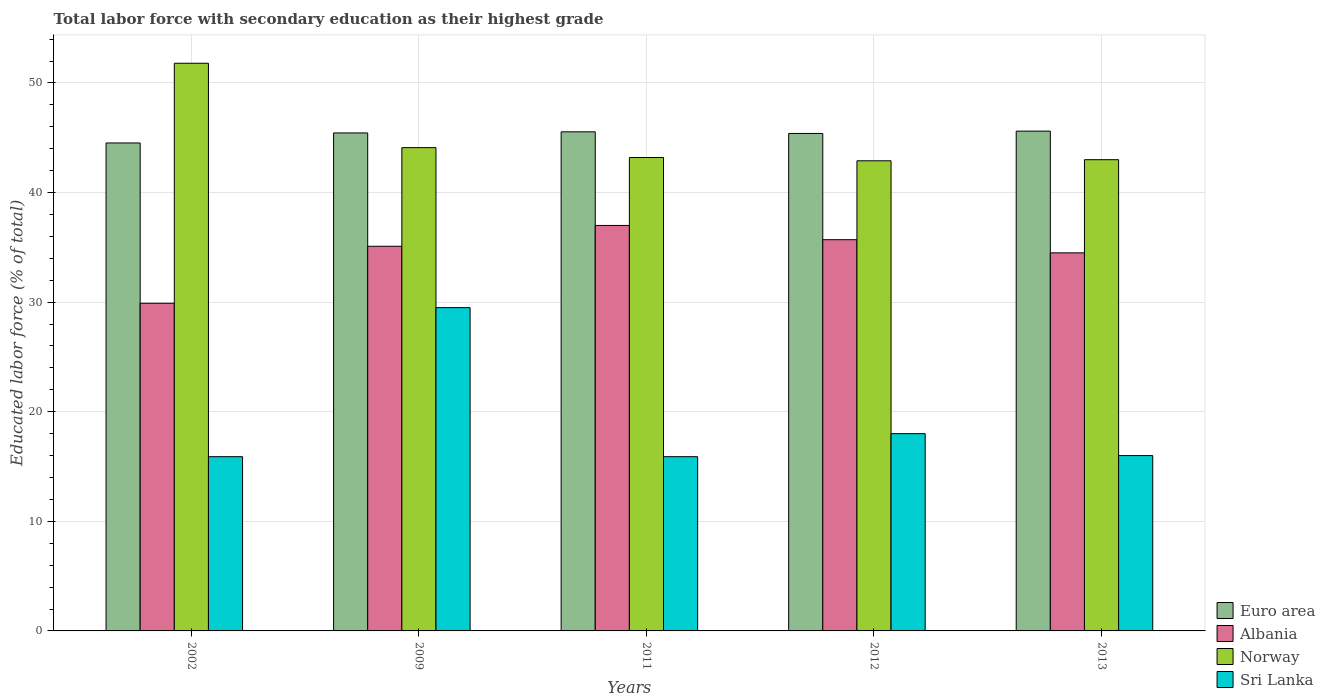How many different coloured bars are there?
Provide a short and direct response. 4. How many groups of bars are there?
Provide a short and direct response. 5. How many bars are there on the 3rd tick from the right?
Offer a terse response. 4. In how many cases, is the number of bars for a given year not equal to the number of legend labels?
Your answer should be very brief. 0. What is the percentage of total labor force with primary education in Euro area in 2011?
Your answer should be very brief. 45.54. Across all years, what is the maximum percentage of total labor force with primary education in Sri Lanka?
Offer a terse response. 29.5. Across all years, what is the minimum percentage of total labor force with primary education in Albania?
Provide a succinct answer. 29.9. In which year was the percentage of total labor force with primary education in Norway minimum?
Keep it short and to the point. 2012. What is the total percentage of total labor force with primary education in Euro area in the graph?
Provide a succinct answer. 226.51. What is the difference between the percentage of total labor force with primary education in Euro area in 2011 and that in 2013?
Your answer should be compact. -0.06. What is the difference between the percentage of total labor force with primary education in Euro area in 2009 and the percentage of total labor force with primary education in Sri Lanka in 2013?
Ensure brevity in your answer.  29.44. What is the average percentage of total labor force with primary education in Sri Lanka per year?
Make the answer very short. 19.06. In the year 2013, what is the difference between the percentage of total labor force with primary education in Albania and percentage of total labor force with primary education in Euro area?
Provide a short and direct response. -11.11. What is the ratio of the percentage of total labor force with primary education in Euro area in 2002 to that in 2013?
Your answer should be very brief. 0.98. Is the percentage of total labor force with primary education in Albania in 2002 less than that in 2009?
Your response must be concise. Yes. Is the difference between the percentage of total labor force with primary education in Albania in 2002 and 2012 greater than the difference between the percentage of total labor force with primary education in Euro area in 2002 and 2012?
Offer a very short reply. No. What is the difference between the highest and the second highest percentage of total labor force with primary education in Sri Lanka?
Make the answer very short. 11.5. What is the difference between the highest and the lowest percentage of total labor force with primary education in Sri Lanka?
Provide a succinct answer. 13.6. In how many years, is the percentage of total labor force with primary education in Sri Lanka greater than the average percentage of total labor force with primary education in Sri Lanka taken over all years?
Provide a short and direct response. 1. Is it the case that in every year, the sum of the percentage of total labor force with primary education in Norway and percentage of total labor force with primary education in Sri Lanka is greater than the sum of percentage of total labor force with primary education in Albania and percentage of total labor force with primary education in Euro area?
Offer a very short reply. No. What does the 1st bar from the right in 2002 represents?
Your response must be concise. Sri Lanka. Are all the bars in the graph horizontal?
Make the answer very short. No. How many years are there in the graph?
Offer a very short reply. 5. Does the graph contain grids?
Your answer should be very brief. Yes. Where does the legend appear in the graph?
Ensure brevity in your answer.  Bottom right. How many legend labels are there?
Give a very brief answer. 4. How are the legend labels stacked?
Provide a succinct answer. Vertical. What is the title of the graph?
Give a very brief answer. Total labor force with secondary education as their highest grade. Does "Papua New Guinea" appear as one of the legend labels in the graph?
Provide a succinct answer. No. What is the label or title of the X-axis?
Offer a terse response. Years. What is the label or title of the Y-axis?
Ensure brevity in your answer.  Educated labor force (% of total). What is the Educated labor force (% of total) of Euro area in 2002?
Your response must be concise. 44.53. What is the Educated labor force (% of total) of Albania in 2002?
Give a very brief answer. 29.9. What is the Educated labor force (% of total) of Norway in 2002?
Give a very brief answer. 51.8. What is the Educated labor force (% of total) in Sri Lanka in 2002?
Provide a short and direct response. 15.9. What is the Educated labor force (% of total) of Euro area in 2009?
Give a very brief answer. 45.44. What is the Educated labor force (% of total) in Albania in 2009?
Your response must be concise. 35.1. What is the Educated labor force (% of total) of Norway in 2009?
Keep it short and to the point. 44.1. What is the Educated labor force (% of total) of Sri Lanka in 2009?
Your response must be concise. 29.5. What is the Educated labor force (% of total) in Euro area in 2011?
Provide a succinct answer. 45.54. What is the Educated labor force (% of total) of Albania in 2011?
Offer a terse response. 37. What is the Educated labor force (% of total) in Norway in 2011?
Provide a short and direct response. 43.2. What is the Educated labor force (% of total) of Sri Lanka in 2011?
Offer a very short reply. 15.9. What is the Educated labor force (% of total) of Euro area in 2012?
Provide a short and direct response. 45.39. What is the Educated labor force (% of total) of Albania in 2012?
Provide a short and direct response. 35.7. What is the Educated labor force (% of total) in Norway in 2012?
Make the answer very short. 42.9. What is the Educated labor force (% of total) in Euro area in 2013?
Give a very brief answer. 45.61. What is the Educated labor force (% of total) in Albania in 2013?
Your answer should be compact. 34.5. What is the Educated labor force (% of total) of Sri Lanka in 2013?
Offer a very short reply. 16. Across all years, what is the maximum Educated labor force (% of total) in Euro area?
Your answer should be very brief. 45.61. Across all years, what is the maximum Educated labor force (% of total) in Norway?
Your answer should be compact. 51.8. Across all years, what is the maximum Educated labor force (% of total) in Sri Lanka?
Provide a short and direct response. 29.5. Across all years, what is the minimum Educated labor force (% of total) in Euro area?
Offer a terse response. 44.53. Across all years, what is the minimum Educated labor force (% of total) in Albania?
Make the answer very short. 29.9. Across all years, what is the minimum Educated labor force (% of total) in Norway?
Your answer should be very brief. 42.9. Across all years, what is the minimum Educated labor force (% of total) in Sri Lanka?
Your response must be concise. 15.9. What is the total Educated labor force (% of total) in Euro area in the graph?
Offer a terse response. 226.51. What is the total Educated labor force (% of total) of Albania in the graph?
Provide a short and direct response. 172.2. What is the total Educated labor force (% of total) in Norway in the graph?
Offer a very short reply. 225. What is the total Educated labor force (% of total) of Sri Lanka in the graph?
Your answer should be compact. 95.3. What is the difference between the Educated labor force (% of total) of Euro area in 2002 and that in 2009?
Your answer should be very brief. -0.91. What is the difference between the Educated labor force (% of total) of Albania in 2002 and that in 2009?
Ensure brevity in your answer.  -5.2. What is the difference between the Educated labor force (% of total) of Norway in 2002 and that in 2009?
Your response must be concise. 7.7. What is the difference between the Educated labor force (% of total) of Sri Lanka in 2002 and that in 2009?
Make the answer very short. -13.6. What is the difference between the Educated labor force (% of total) of Euro area in 2002 and that in 2011?
Your answer should be compact. -1.02. What is the difference between the Educated labor force (% of total) in Albania in 2002 and that in 2011?
Make the answer very short. -7.1. What is the difference between the Educated labor force (% of total) of Norway in 2002 and that in 2011?
Keep it short and to the point. 8.6. What is the difference between the Educated labor force (% of total) in Euro area in 2002 and that in 2012?
Offer a terse response. -0.87. What is the difference between the Educated labor force (% of total) of Albania in 2002 and that in 2012?
Make the answer very short. -5.8. What is the difference between the Educated labor force (% of total) in Sri Lanka in 2002 and that in 2012?
Offer a very short reply. -2.1. What is the difference between the Educated labor force (% of total) in Euro area in 2002 and that in 2013?
Offer a very short reply. -1.08. What is the difference between the Educated labor force (% of total) in Albania in 2002 and that in 2013?
Provide a short and direct response. -4.6. What is the difference between the Educated labor force (% of total) in Sri Lanka in 2002 and that in 2013?
Provide a succinct answer. -0.1. What is the difference between the Educated labor force (% of total) of Euro area in 2009 and that in 2011?
Offer a very short reply. -0.1. What is the difference between the Educated labor force (% of total) of Norway in 2009 and that in 2011?
Provide a succinct answer. 0.9. What is the difference between the Educated labor force (% of total) of Euro area in 2009 and that in 2012?
Provide a succinct answer. 0.05. What is the difference between the Educated labor force (% of total) in Sri Lanka in 2009 and that in 2012?
Your response must be concise. 11.5. What is the difference between the Educated labor force (% of total) of Euro area in 2009 and that in 2013?
Keep it short and to the point. -0.16. What is the difference between the Educated labor force (% of total) of Norway in 2009 and that in 2013?
Your response must be concise. 1.1. What is the difference between the Educated labor force (% of total) of Euro area in 2011 and that in 2012?
Offer a very short reply. 0.15. What is the difference between the Educated labor force (% of total) in Sri Lanka in 2011 and that in 2012?
Your answer should be very brief. -2.1. What is the difference between the Educated labor force (% of total) of Euro area in 2011 and that in 2013?
Give a very brief answer. -0.06. What is the difference between the Educated labor force (% of total) in Euro area in 2012 and that in 2013?
Offer a terse response. -0.21. What is the difference between the Educated labor force (% of total) of Albania in 2012 and that in 2013?
Offer a very short reply. 1.2. What is the difference between the Educated labor force (% of total) in Sri Lanka in 2012 and that in 2013?
Offer a terse response. 2. What is the difference between the Educated labor force (% of total) in Euro area in 2002 and the Educated labor force (% of total) in Albania in 2009?
Keep it short and to the point. 9.43. What is the difference between the Educated labor force (% of total) of Euro area in 2002 and the Educated labor force (% of total) of Norway in 2009?
Offer a terse response. 0.43. What is the difference between the Educated labor force (% of total) of Euro area in 2002 and the Educated labor force (% of total) of Sri Lanka in 2009?
Provide a succinct answer. 15.03. What is the difference between the Educated labor force (% of total) in Albania in 2002 and the Educated labor force (% of total) in Norway in 2009?
Make the answer very short. -14.2. What is the difference between the Educated labor force (% of total) of Norway in 2002 and the Educated labor force (% of total) of Sri Lanka in 2009?
Give a very brief answer. 22.3. What is the difference between the Educated labor force (% of total) in Euro area in 2002 and the Educated labor force (% of total) in Albania in 2011?
Keep it short and to the point. 7.53. What is the difference between the Educated labor force (% of total) of Euro area in 2002 and the Educated labor force (% of total) of Norway in 2011?
Your response must be concise. 1.33. What is the difference between the Educated labor force (% of total) in Euro area in 2002 and the Educated labor force (% of total) in Sri Lanka in 2011?
Offer a very short reply. 28.63. What is the difference between the Educated labor force (% of total) in Norway in 2002 and the Educated labor force (% of total) in Sri Lanka in 2011?
Make the answer very short. 35.9. What is the difference between the Educated labor force (% of total) in Euro area in 2002 and the Educated labor force (% of total) in Albania in 2012?
Your answer should be compact. 8.83. What is the difference between the Educated labor force (% of total) of Euro area in 2002 and the Educated labor force (% of total) of Norway in 2012?
Your answer should be compact. 1.63. What is the difference between the Educated labor force (% of total) of Euro area in 2002 and the Educated labor force (% of total) of Sri Lanka in 2012?
Your response must be concise. 26.53. What is the difference between the Educated labor force (% of total) of Norway in 2002 and the Educated labor force (% of total) of Sri Lanka in 2012?
Provide a short and direct response. 33.8. What is the difference between the Educated labor force (% of total) of Euro area in 2002 and the Educated labor force (% of total) of Albania in 2013?
Make the answer very short. 10.03. What is the difference between the Educated labor force (% of total) of Euro area in 2002 and the Educated labor force (% of total) of Norway in 2013?
Ensure brevity in your answer.  1.53. What is the difference between the Educated labor force (% of total) in Euro area in 2002 and the Educated labor force (% of total) in Sri Lanka in 2013?
Offer a terse response. 28.53. What is the difference between the Educated labor force (% of total) in Albania in 2002 and the Educated labor force (% of total) in Sri Lanka in 2013?
Offer a terse response. 13.9. What is the difference between the Educated labor force (% of total) of Norway in 2002 and the Educated labor force (% of total) of Sri Lanka in 2013?
Your response must be concise. 35.8. What is the difference between the Educated labor force (% of total) of Euro area in 2009 and the Educated labor force (% of total) of Albania in 2011?
Provide a short and direct response. 8.44. What is the difference between the Educated labor force (% of total) of Euro area in 2009 and the Educated labor force (% of total) of Norway in 2011?
Offer a very short reply. 2.24. What is the difference between the Educated labor force (% of total) of Euro area in 2009 and the Educated labor force (% of total) of Sri Lanka in 2011?
Give a very brief answer. 29.54. What is the difference between the Educated labor force (% of total) in Albania in 2009 and the Educated labor force (% of total) in Norway in 2011?
Make the answer very short. -8.1. What is the difference between the Educated labor force (% of total) of Albania in 2009 and the Educated labor force (% of total) of Sri Lanka in 2011?
Your response must be concise. 19.2. What is the difference between the Educated labor force (% of total) in Norway in 2009 and the Educated labor force (% of total) in Sri Lanka in 2011?
Provide a short and direct response. 28.2. What is the difference between the Educated labor force (% of total) of Euro area in 2009 and the Educated labor force (% of total) of Albania in 2012?
Offer a terse response. 9.74. What is the difference between the Educated labor force (% of total) in Euro area in 2009 and the Educated labor force (% of total) in Norway in 2012?
Provide a short and direct response. 2.54. What is the difference between the Educated labor force (% of total) of Euro area in 2009 and the Educated labor force (% of total) of Sri Lanka in 2012?
Give a very brief answer. 27.44. What is the difference between the Educated labor force (% of total) of Albania in 2009 and the Educated labor force (% of total) of Norway in 2012?
Make the answer very short. -7.8. What is the difference between the Educated labor force (% of total) of Norway in 2009 and the Educated labor force (% of total) of Sri Lanka in 2012?
Provide a short and direct response. 26.1. What is the difference between the Educated labor force (% of total) in Euro area in 2009 and the Educated labor force (% of total) in Albania in 2013?
Keep it short and to the point. 10.94. What is the difference between the Educated labor force (% of total) of Euro area in 2009 and the Educated labor force (% of total) of Norway in 2013?
Your answer should be very brief. 2.44. What is the difference between the Educated labor force (% of total) in Euro area in 2009 and the Educated labor force (% of total) in Sri Lanka in 2013?
Offer a terse response. 29.44. What is the difference between the Educated labor force (% of total) in Norway in 2009 and the Educated labor force (% of total) in Sri Lanka in 2013?
Your answer should be very brief. 28.1. What is the difference between the Educated labor force (% of total) in Euro area in 2011 and the Educated labor force (% of total) in Albania in 2012?
Your answer should be very brief. 9.84. What is the difference between the Educated labor force (% of total) of Euro area in 2011 and the Educated labor force (% of total) of Norway in 2012?
Provide a succinct answer. 2.64. What is the difference between the Educated labor force (% of total) in Euro area in 2011 and the Educated labor force (% of total) in Sri Lanka in 2012?
Offer a very short reply. 27.54. What is the difference between the Educated labor force (% of total) in Albania in 2011 and the Educated labor force (% of total) in Norway in 2012?
Your answer should be very brief. -5.9. What is the difference between the Educated labor force (% of total) of Norway in 2011 and the Educated labor force (% of total) of Sri Lanka in 2012?
Your response must be concise. 25.2. What is the difference between the Educated labor force (% of total) of Euro area in 2011 and the Educated labor force (% of total) of Albania in 2013?
Provide a short and direct response. 11.04. What is the difference between the Educated labor force (% of total) of Euro area in 2011 and the Educated labor force (% of total) of Norway in 2013?
Provide a short and direct response. 2.54. What is the difference between the Educated labor force (% of total) of Euro area in 2011 and the Educated labor force (% of total) of Sri Lanka in 2013?
Offer a very short reply. 29.54. What is the difference between the Educated labor force (% of total) in Albania in 2011 and the Educated labor force (% of total) in Norway in 2013?
Your response must be concise. -6. What is the difference between the Educated labor force (% of total) in Albania in 2011 and the Educated labor force (% of total) in Sri Lanka in 2013?
Your response must be concise. 21. What is the difference between the Educated labor force (% of total) in Norway in 2011 and the Educated labor force (% of total) in Sri Lanka in 2013?
Keep it short and to the point. 27.2. What is the difference between the Educated labor force (% of total) of Euro area in 2012 and the Educated labor force (% of total) of Albania in 2013?
Your answer should be compact. 10.89. What is the difference between the Educated labor force (% of total) in Euro area in 2012 and the Educated labor force (% of total) in Norway in 2013?
Keep it short and to the point. 2.39. What is the difference between the Educated labor force (% of total) of Euro area in 2012 and the Educated labor force (% of total) of Sri Lanka in 2013?
Provide a short and direct response. 29.39. What is the difference between the Educated labor force (% of total) of Albania in 2012 and the Educated labor force (% of total) of Norway in 2013?
Your response must be concise. -7.3. What is the difference between the Educated labor force (% of total) in Albania in 2012 and the Educated labor force (% of total) in Sri Lanka in 2013?
Your answer should be very brief. 19.7. What is the difference between the Educated labor force (% of total) of Norway in 2012 and the Educated labor force (% of total) of Sri Lanka in 2013?
Ensure brevity in your answer.  26.9. What is the average Educated labor force (% of total) of Euro area per year?
Provide a succinct answer. 45.3. What is the average Educated labor force (% of total) of Albania per year?
Make the answer very short. 34.44. What is the average Educated labor force (% of total) of Norway per year?
Make the answer very short. 45. What is the average Educated labor force (% of total) of Sri Lanka per year?
Give a very brief answer. 19.06. In the year 2002, what is the difference between the Educated labor force (% of total) of Euro area and Educated labor force (% of total) of Albania?
Your answer should be very brief. 14.63. In the year 2002, what is the difference between the Educated labor force (% of total) in Euro area and Educated labor force (% of total) in Norway?
Provide a short and direct response. -7.27. In the year 2002, what is the difference between the Educated labor force (% of total) of Euro area and Educated labor force (% of total) of Sri Lanka?
Provide a short and direct response. 28.63. In the year 2002, what is the difference between the Educated labor force (% of total) in Albania and Educated labor force (% of total) in Norway?
Make the answer very short. -21.9. In the year 2002, what is the difference between the Educated labor force (% of total) of Norway and Educated labor force (% of total) of Sri Lanka?
Offer a very short reply. 35.9. In the year 2009, what is the difference between the Educated labor force (% of total) in Euro area and Educated labor force (% of total) in Albania?
Give a very brief answer. 10.34. In the year 2009, what is the difference between the Educated labor force (% of total) in Euro area and Educated labor force (% of total) in Norway?
Offer a very short reply. 1.34. In the year 2009, what is the difference between the Educated labor force (% of total) of Euro area and Educated labor force (% of total) of Sri Lanka?
Your response must be concise. 15.94. In the year 2009, what is the difference between the Educated labor force (% of total) in Albania and Educated labor force (% of total) in Norway?
Offer a terse response. -9. In the year 2011, what is the difference between the Educated labor force (% of total) in Euro area and Educated labor force (% of total) in Albania?
Your response must be concise. 8.54. In the year 2011, what is the difference between the Educated labor force (% of total) of Euro area and Educated labor force (% of total) of Norway?
Your response must be concise. 2.34. In the year 2011, what is the difference between the Educated labor force (% of total) in Euro area and Educated labor force (% of total) in Sri Lanka?
Your answer should be very brief. 29.64. In the year 2011, what is the difference between the Educated labor force (% of total) in Albania and Educated labor force (% of total) in Norway?
Provide a short and direct response. -6.2. In the year 2011, what is the difference between the Educated labor force (% of total) in Albania and Educated labor force (% of total) in Sri Lanka?
Make the answer very short. 21.1. In the year 2011, what is the difference between the Educated labor force (% of total) in Norway and Educated labor force (% of total) in Sri Lanka?
Your answer should be very brief. 27.3. In the year 2012, what is the difference between the Educated labor force (% of total) of Euro area and Educated labor force (% of total) of Albania?
Provide a succinct answer. 9.69. In the year 2012, what is the difference between the Educated labor force (% of total) of Euro area and Educated labor force (% of total) of Norway?
Your answer should be very brief. 2.49. In the year 2012, what is the difference between the Educated labor force (% of total) of Euro area and Educated labor force (% of total) of Sri Lanka?
Provide a succinct answer. 27.39. In the year 2012, what is the difference between the Educated labor force (% of total) of Albania and Educated labor force (% of total) of Norway?
Keep it short and to the point. -7.2. In the year 2012, what is the difference between the Educated labor force (% of total) of Albania and Educated labor force (% of total) of Sri Lanka?
Your response must be concise. 17.7. In the year 2012, what is the difference between the Educated labor force (% of total) of Norway and Educated labor force (% of total) of Sri Lanka?
Your response must be concise. 24.9. In the year 2013, what is the difference between the Educated labor force (% of total) in Euro area and Educated labor force (% of total) in Albania?
Your response must be concise. 11.11. In the year 2013, what is the difference between the Educated labor force (% of total) of Euro area and Educated labor force (% of total) of Norway?
Offer a very short reply. 2.61. In the year 2013, what is the difference between the Educated labor force (% of total) of Euro area and Educated labor force (% of total) of Sri Lanka?
Your answer should be very brief. 29.61. In the year 2013, what is the difference between the Educated labor force (% of total) of Norway and Educated labor force (% of total) of Sri Lanka?
Provide a succinct answer. 27. What is the ratio of the Educated labor force (% of total) in Euro area in 2002 to that in 2009?
Provide a succinct answer. 0.98. What is the ratio of the Educated labor force (% of total) in Albania in 2002 to that in 2009?
Your answer should be compact. 0.85. What is the ratio of the Educated labor force (% of total) of Norway in 2002 to that in 2009?
Your answer should be compact. 1.17. What is the ratio of the Educated labor force (% of total) in Sri Lanka in 2002 to that in 2009?
Ensure brevity in your answer.  0.54. What is the ratio of the Educated labor force (% of total) in Euro area in 2002 to that in 2011?
Provide a short and direct response. 0.98. What is the ratio of the Educated labor force (% of total) of Albania in 2002 to that in 2011?
Make the answer very short. 0.81. What is the ratio of the Educated labor force (% of total) in Norway in 2002 to that in 2011?
Your answer should be compact. 1.2. What is the ratio of the Educated labor force (% of total) of Euro area in 2002 to that in 2012?
Your answer should be very brief. 0.98. What is the ratio of the Educated labor force (% of total) of Albania in 2002 to that in 2012?
Ensure brevity in your answer.  0.84. What is the ratio of the Educated labor force (% of total) in Norway in 2002 to that in 2012?
Keep it short and to the point. 1.21. What is the ratio of the Educated labor force (% of total) of Sri Lanka in 2002 to that in 2012?
Your answer should be very brief. 0.88. What is the ratio of the Educated labor force (% of total) in Euro area in 2002 to that in 2013?
Your answer should be compact. 0.98. What is the ratio of the Educated labor force (% of total) in Albania in 2002 to that in 2013?
Your response must be concise. 0.87. What is the ratio of the Educated labor force (% of total) in Norway in 2002 to that in 2013?
Make the answer very short. 1.2. What is the ratio of the Educated labor force (% of total) in Sri Lanka in 2002 to that in 2013?
Make the answer very short. 0.99. What is the ratio of the Educated labor force (% of total) of Euro area in 2009 to that in 2011?
Offer a very short reply. 1. What is the ratio of the Educated labor force (% of total) of Albania in 2009 to that in 2011?
Keep it short and to the point. 0.95. What is the ratio of the Educated labor force (% of total) in Norway in 2009 to that in 2011?
Give a very brief answer. 1.02. What is the ratio of the Educated labor force (% of total) in Sri Lanka in 2009 to that in 2011?
Offer a terse response. 1.86. What is the ratio of the Educated labor force (% of total) of Albania in 2009 to that in 2012?
Offer a terse response. 0.98. What is the ratio of the Educated labor force (% of total) of Norway in 2009 to that in 2012?
Keep it short and to the point. 1.03. What is the ratio of the Educated labor force (% of total) in Sri Lanka in 2009 to that in 2012?
Provide a short and direct response. 1.64. What is the ratio of the Educated labor force (% of total) in Euro area in 2009 to that in 2013?
Give a very brief answer. 1. What is the ratio of the Educated labor force (% of total) in Albania in 2009 to that in 2013?
Keep it short and to the point. 1.02. What is the ratio of the Educated labor force (% of total) in Norway in 2009 to that in 2013?
Make the answer very short. 1.03. What is the ratio of the Educated labor force (% of total) in Sri Lanka in 2009 to that in 2013?
Provide a short and direct response. 1.84. What is the ratio of the Educated labor force (% of total) in Albania in 2011 to that in 2012?
Make the answer very short. 1.04. What is the ratio of the Educated labor force (% of total) in Norway in 2011 to that in 2012?
Your response must be concise. 1.01. What is the ratio of the Educated labor force (% of total) in Sri Lanka in 2011 to that in 2012?
Give a very brief answer. 0.88. What is the ratio of the Educated labor force (% of total) of Euro area in 2011 to that in 2013?
Make the answer very short. 1. What is the ratio of the Educated labor force (% of total) in Albania in 2011 to that in 2013?
Your response must be concise. 1.07. What is the ratio of the Educated labor force (% of total) in Norway in 2011 to that in 2013?
Offer a terse response. 1. What is the ratio of the Educated labor force (% of total) in Euro area in 2012 to that in 2013?
Make the answer very short. 1. What is the ratio of the Educated labor force (% of total) in Albania in 2012 to that in 2013?
Your answer should be compact. 1.03. What is the ratio of the Educated labor force (% of total) in Sri Lanka in 2012 to that in 2013?
Your response must be concise. 1.12. What is the difference between the highest and the second highest Educated labor force (% of total) in Euro area?
Keep it short and to the point. 0.06. What is the difference between the highest and the second highest Educated labor force (% of total) in Albania?
Give a very brief answer. 1.3. What is the difference between the highest and the second highest Educated labor force (% of total) in Sri Lanka?
Your answer should be compact. 11.5. What is the difference between the highest and the lowest Educated labor force (% of total) in Euro area?
Provide a short and direct response. 1.08. What is the difference between the highest and the lowest Educated labor force (% of total) of Albania?
Your answer should be very brief. 7.1. What is the difference between the highest and the lowest Educated labor force (% of total) of Norway?
Your response must be concise. 8.9. What is the difference between the highest and the lowest Educated labor force (% of total) in Sri Lanka?
Provide a succinct answer. 13.6. 